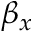Convert formula to latex. <formula><loc_0><loc_0><loc_500><loc_500>\beta _ { x }</formula> 